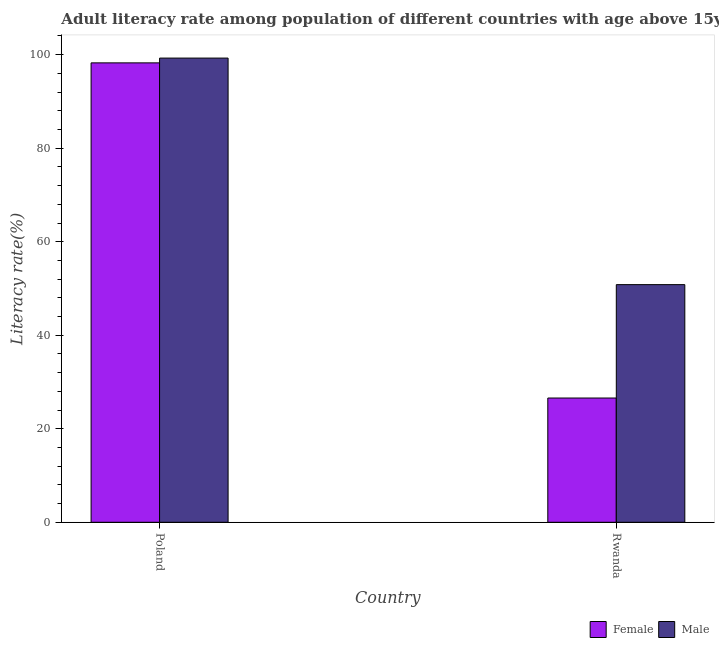How many different coloured bars are there?
Provide a succinct answer. 2. How many groups of bars are there?
Your answer should be very brief. 2. Are the number of bars per tick equal to the number of legend labels?
Ensure brevity in your answer.  Yes. Are the number of bars on each tick of the X-axis equal?
Keep it short and to the point. Yes. How many bars are there on the 1st tick from the right?
Offer a very short reply. 2. What is the label of the 2nd group of bars from the left?
Your answer should be very brief. Rwanda. In how many cases, is the number of bars for a given country not equal to the number of legend labels?
Offer a terse response. 0. What is the female adult literacy rate in Rwanda?
Ensure brevity in your answer.  26.57. Across all countries, what is the maximum male adult literacy rate?
Offer a very short reply. 99.28. Across all countries, what is the minimum male adult literacy rate?
Your response must be concise. 50.82. In which country was the female adult literacy rate minimum?
Keep it short and to the point. Rwanda. What is the total female adult literacy rate in the graph?
Your answer should be compact. 124.83. What is the difference between the male adult literacy rate in Poland and that in Rwanda?
Your answer should be very brief. 48.45. What is the difference between the male adult literacy rate in Poland and the female adult literacy rate in Rwanda?
Your answer should be compact. 72.7. What is the average female adult literacy rate per country?
Make the answer very short. 62.41. What is the difference between the female adult literacy rate and male adult literacy rate in Rwanda?
Give a very brief answer. -24.25. In how many countries, is the female adult literacy rate greater than 28 %?
Your answer should be compact. 1. What is the ratio of the male adult literacy rate in Poland to that in Rwanda?
Make the answer very short. 1.95. Is the male adult literacy rate in Poland less than that in Rwanda?
Keep it short and to the point. No. How many bars are there?
Offer a terse response. 4. Are the values on the major ticks of Y-axis written in scientific E-notation?
Ensure brevity in your answer.  No. Does the graph contain any zero values?
Ensure brevity in your answer.  No. How many legend labels are there?
Your answer should be compact. 2. How are the legend labels stacked?
Your answer should be very brief. Horizontal. What is the title of the graph?
Your response must be concise. Adult literacy rate among population of different countries with age above 15years. What is the label or title of the X-axis?
Provide a short and direct response. Country. What is the label or title of the Y-axis?
Your answer should be very brief. Literacy rate(%). What is the Literacy rate(%) of Female in Poland?
Make the answer very short. 98.25. What is the Literacy rate(%) of Male in Poland?
Offer a very short reply. 99.28. What is the Literacy rate(%) in Female in Rwanda?
Your answer should be very brief. 26.57. What is the Literacy rate(%) of Male in Rwanda?
Make the answer very short. 50.82. Across all countries, what is the maximum Literacy rate(%) of Female?
Provide a short and direct response. 98.25. Across all countries, what is the maximum Literacy rate(%) of Male?
Provide a succinct answer. 99.28. Across all countries, what is the minimum Literacy rate(%) of Female?
Ensure brevity in your answer.  26.57. Across all countries, what is the minimum Literacy rate(%) in Male?
Offer a terse response. 50.82. What is the total Literacy rate(%) of Female in the graph?
Your answer should be very brief. 124.83. What is the total Literacy rate(%) of Male in the graph?
Make the answer very short. 150.1. What is the difference between the Literacy rate(%) in Female in Poland and that in Rwanda?
Your response must be concise. 71.68. What is the difference between the Literacy rate(%) in Male in Poland and that in Rwanda?
Provide a short and direct response. 48.45. What is the difference between the Literacy rate(%) in Female in Poland and the Literacy rate(%) in Male in Rwanda?
Your response must be concise. 47.43. What is the average Literacy rate(%) in Female per country?
Provide a succinct answer. 62.41. What is the average Literacy rate(%) of Male per country?
Provide a short and direct response. 75.05. What is the difference between the Literacy rate(%) of Female and Literacy rate(%) of Male in Poland?
Keep it short and to the point. -1.02. What is the difference between the Literacy rate(%) in Female and Literacy rate(%) in Male in Rwanda?
Provide a short and direct response. -24.25. What is the ratio of the Literacy rate(%) in Female in Poland to that in Rwanda?
Your answer should be very brief. 3.7. What is the ratio of the Literacy rate(%) of Male in Poland to that in Rwanda?
Provide a short and direct response. 1.95. What is the difference between the highest and the second highest Literacy rate(%) in Female?
Ensure brevity in your answer.  71.68. What is the difference between the highest and the second highest Literacy rate(%) of Male?
Keep it short and to the point. 48.45. What is the difference between the highest and the lowest Literacy rate(%) of Female?
Give a very brief answer. 71.68. What is the difference between the highest and the lowest Literacy rate(%) in Male?
Offer a very short reply. 48.45. 